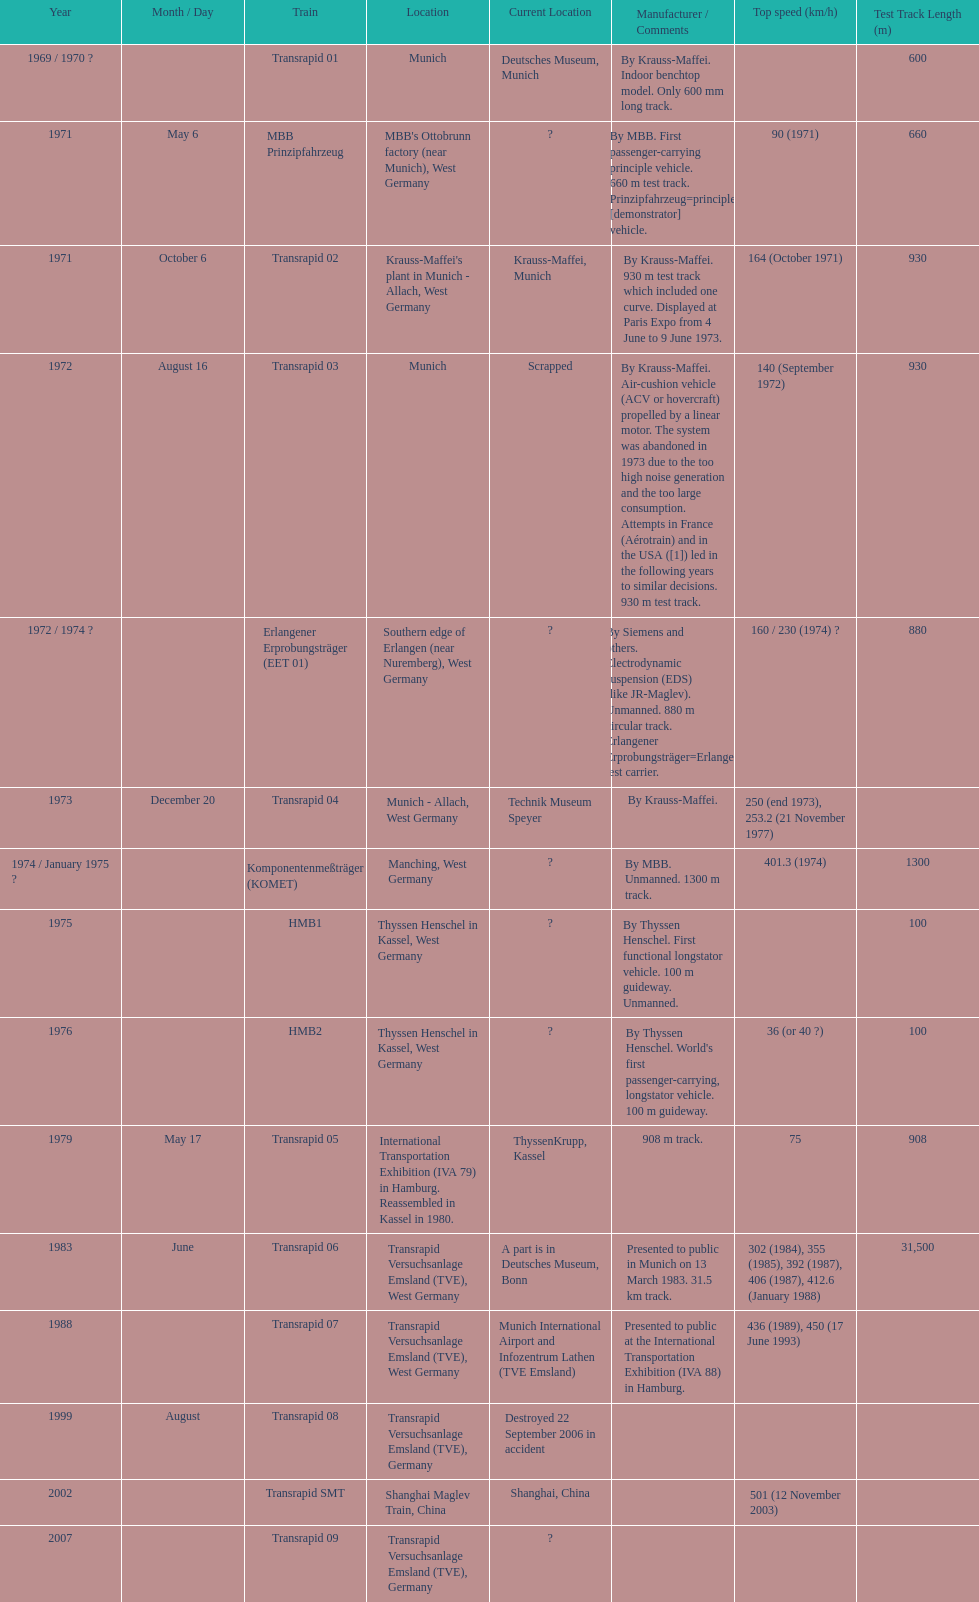What is the number of trains that were either scrapped or destroyed? 2. 